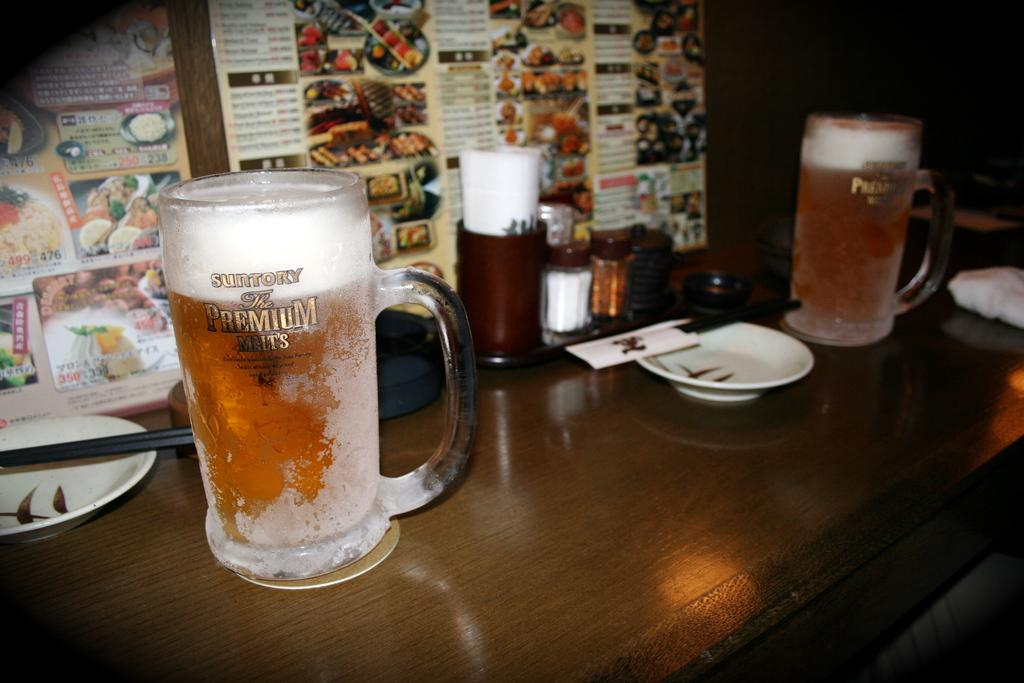<image>
Provide a brief description of the given image. Two frosty mugs of Suntory Premium Malts on a restaurant bar. 